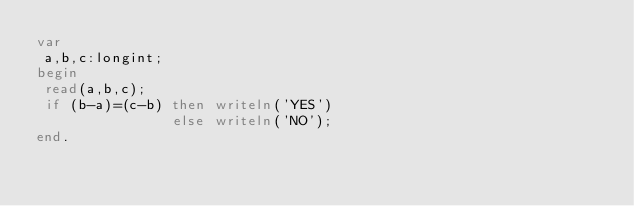<code> <loc_0><loc_0><loc_500><loc_500><_Pascal_>var
 a,b,c:longint;
begin
 read(a,b,c);
 if (b-a)=(c-b) then writeln('YES')
                else writeln('NO');
end.</code> 